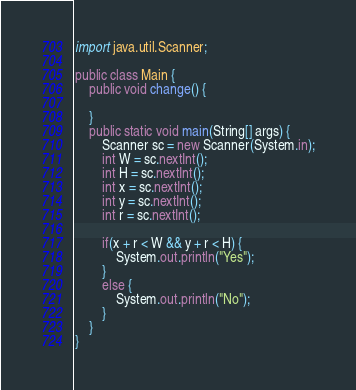<code> <loc_0><loc_0><loc_500><loc_500><_Java_>import java.util.Scanner;

public class Main {
	public void change() {

	}
    public static void main(String[] args) {
        Scanner sc = new Scanner(System.in);
        int W = sc.nextInt();
        int H = sc.nextInt();
        int x = sc.nextInt();
        int y = sc.nextInt();
        int r = sc.nextInt();
        
        if(x + r < W && y + r < H) {
        	System.out.println("Yes");
        }
        else {
        	System.out.println("No");
        }
    }
}
</code> 